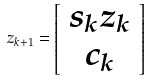Convert formula to latex. <formula><loc_0><loc_0><loc_500><loc_500>z _ { k + 1 } = \left [ \begin{array} { c } s _ { k } z _ { k } \\ c _ { k } \end{array} \right ]</formula> 